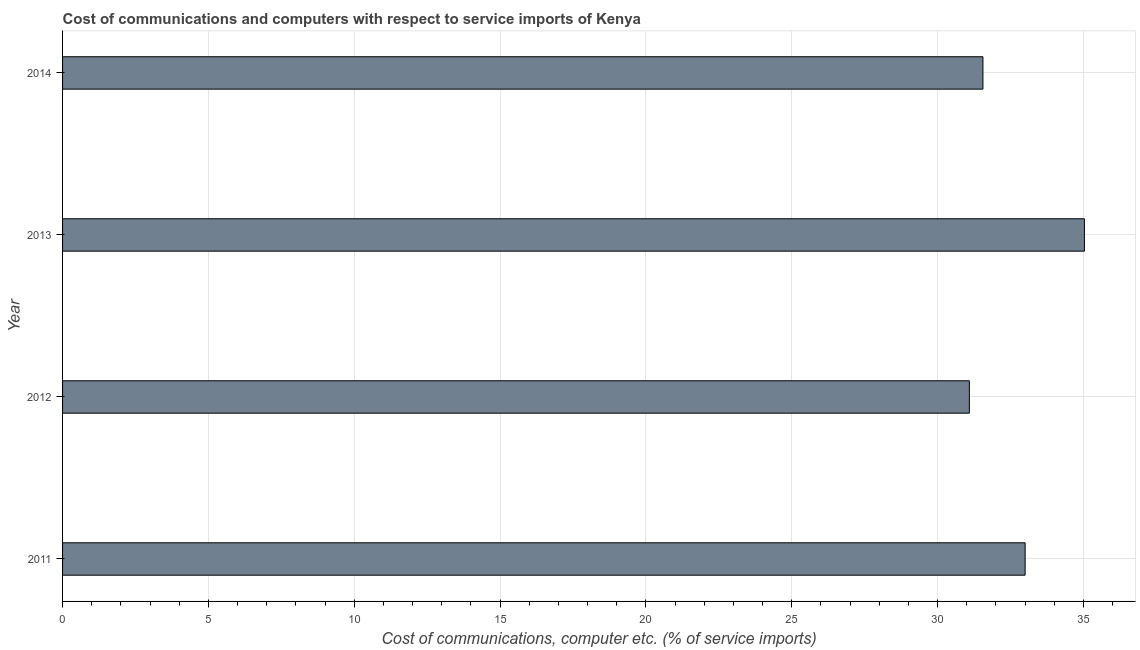Does the graph contain grids?
Your response must be concise. Yes. What is the title of the graph?
Offer a terse response. Cost of communications and computers with respect to service imports of Kenya. What is the label or title of the X-axis?
Provide a succinct answer. Cost of communications, computer etc. (% of service imports). What is the cost of communications and computer in 2013?
Ensure brevity in your answer.  35.03. Across all years, what is the maximum cost of communications and computer?
Your response must be concise. 35.03. Across all years, what is the minimum cost of communications and computer?
Provide a short and direct response. 31.09. In which year was the cost of communications and computer minimum?
Your response must be concise. 2012. What is the sum of the cost of communications and computer?
Give a very brief answer. 130.68. What is the difference between the cost of communications and computer in 2011 and 2012?
Make the answer very short. 1.91. What is the average cost of communications and computer per year?
Make the answer very short. 32.67. What is the median cost of communications and computer?
Your response must be concise. 32.28. Do a majority of the years between 2013 and 2012 (inclusive) have cost of communications and computer greater than 15 %?
Provide a short and direct response. No. What is the ratio of the cost of communications and computer in 2011 to that in 2012?
Your response must be concise. 1.06. Is the difference between the cost of communications and computer in 2013 and 2014 greater than the difference between any two years?
Provide a succinct answer. No. What is the difference between the highest and the second highest cost of communications and computer?
Ensure brevity in your answer.  2.03. Is the sum of the cost of communications and computer in 2011 and 2013 greater than the maximum cost of communications and computer across all years?
Your answer should be very brief. Yes. What is the difference between the highest and the lowest cost of communications and computer?
Your answer should be compact. 3.94. How many bars are there?
Your answer should be compact. 4. Are the values on the major ticks of X-axis written in scientific E-notation?
Your answer should be very brief. No. What is the Cost of communications, computer etc. (% of service imports) of 2011?
Offer a very short reply. 33. What is the Cost of communications, computer etc. (% of service imports) in 2012?
Your response must be concise. 31.09. What is the Cost of communications, computer etc. (% of service imports) in 2013?
Ensure brevity in your answer.  35.03. What is the Cost of communications, computer etc. (% of service imports) in 2014?
Your answer should be compact. 31.55. What is the difference between the Cost of communications, computer etc. (% of service imports) in 2011 and 2012?
Your response must be concise. 1.91. What is the difference between the Cost of communications, computer etc. (% of service imports) in 2011 and 2013?
Offer a very short reply. -2.03. What is the difference between the Cost of communications, computer etc. (% of service imports) in 2011 and 2014?
Your answer should be compact. 1.45. What is the difference between the Cost of communications, computer etc. (% of service imports) in 2012 and 2013?
Your answer should be very brief. -3.94. What is the difference between the Cost of communications, computer etc. (% of service imports) in 2012 and 2014?
Your response must be concise. -0.47. What is the difference between the Cost of communications, computer etc. (% of service imports) in 2013 and 2014?
Make the answer very short. 3.48. What is the ratio of the Cost of communications, computer etc. (% of service imports) in 2011 to that in 2012?
Provide a short and direct response. 1.06. What is the ratio of the Cost of communications, computer etc. (% of service imports) in 2011 to that in 2013?
Your answer should be very brief. 0.94. What is the ratio of the Cost of communications, computer etc. (% of service imports) in 2011 to that in 2014?
Keep it short and to the point. 1.05. What is the ratio of the Cost of communications, computer etc. (% of service imports) in 2012 to that in 2013?
Keep it short and to the point. 0.89. What is the ratio of the Cost of communications, computer etc. (% of service imports) in 2012 to that in 2014?
Your response must be concise. 0.98. What is the ratio of the Cost of communications, computer etc. (% of service imports) in 2013 to that in 2014?
Your answer should be very brief. 1.11. 